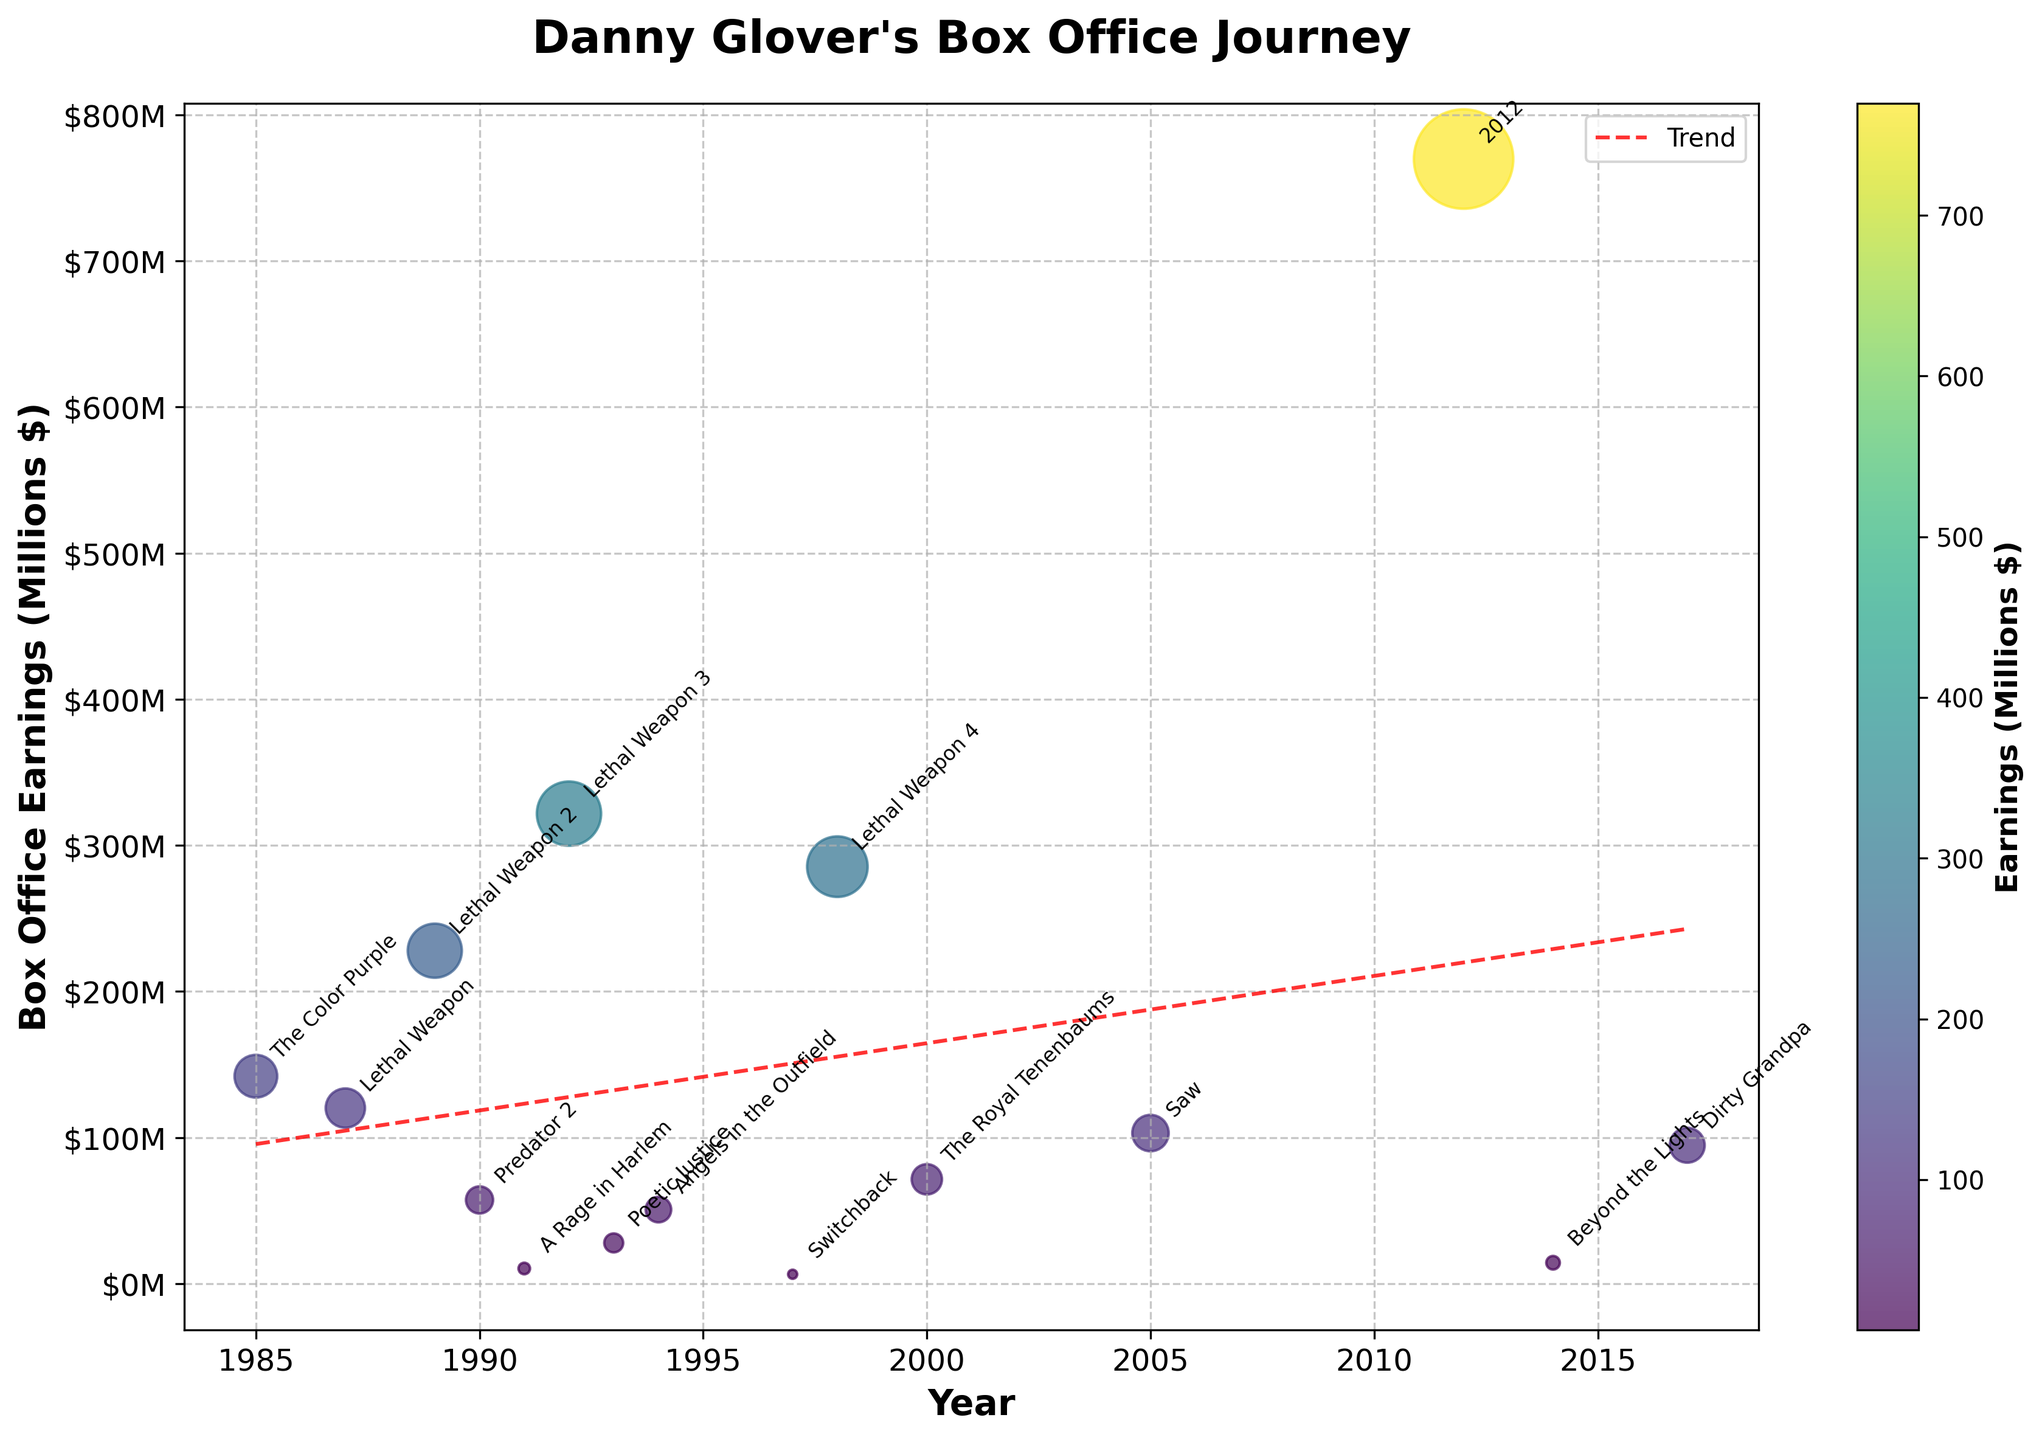What's the title of the plot? The title of the plot is located at the top center of the figure in bold font. It describes the overall theme or subject of the plot.
Answer: Danny Glover's Box Office Journey How are box office earnings represented visually in the plot? The box office earnings are indicated by the size and color of the points (scatter plot) representing different movies. Larger and more vibrantly colored points denote higher earnings.
Answer: Size and color of points Which movie earned the highest box office revenue and in what year? Identification of the highest earning is done by finding the largest and brightest point on the scatter plot. The annotation close to this point reveals the movie and the year of release.
Answer: 2012 in 2012 What is the overall trend in box office earnings over the years? The trend is indicated by the red dashed line added to the plot. This line shows an increasing or decreasing pattern over time.
Answer: Increasing trend Which year featured the lowest box office earnings for Danny Glover and what movie was that? The smallest point on the scatter plot represents the lowest earnings. The annotations beside this point reveal the year and the corresponding movie.
Answer: 1997 with Switchback What is the difference in box office earnings between "Lethal Weapon" (1987) and "Lethal Weapon 4" (1998)? By finding the points and annotations for both movies, we read their earnings directly and then calculate the difference.
Answer: $165.2 million How many movies earned more than $200 million at the box office? Check the plot to identify all points/annotations that surpass the $200 million line on the y-axis and count them.
Answer: 2 movies Which movie had Danny Glover return to the same franchise after the highest gap in years? By identifying movies with sequels and calculating the years between them, the largest gap can be determined.
Answer: Lethal Weapon 4 (1998) after Lethal Weapon 3 (1992) What is the average box office earnings of Danny Glover movies released in the 1990s? Calculate the average by summing up earnings of movies released in the 1990s and dividing by the number of such movies.
Answer: Approx. $131.5 million How does the box office earning of 'Poetic Justice' (1993) compare to 'A Rage in Harlem' (1991)? Locate the points of both movies and compare their y-axis positions in terms of millions.
Answer: 'Poetic Justice' earned more 